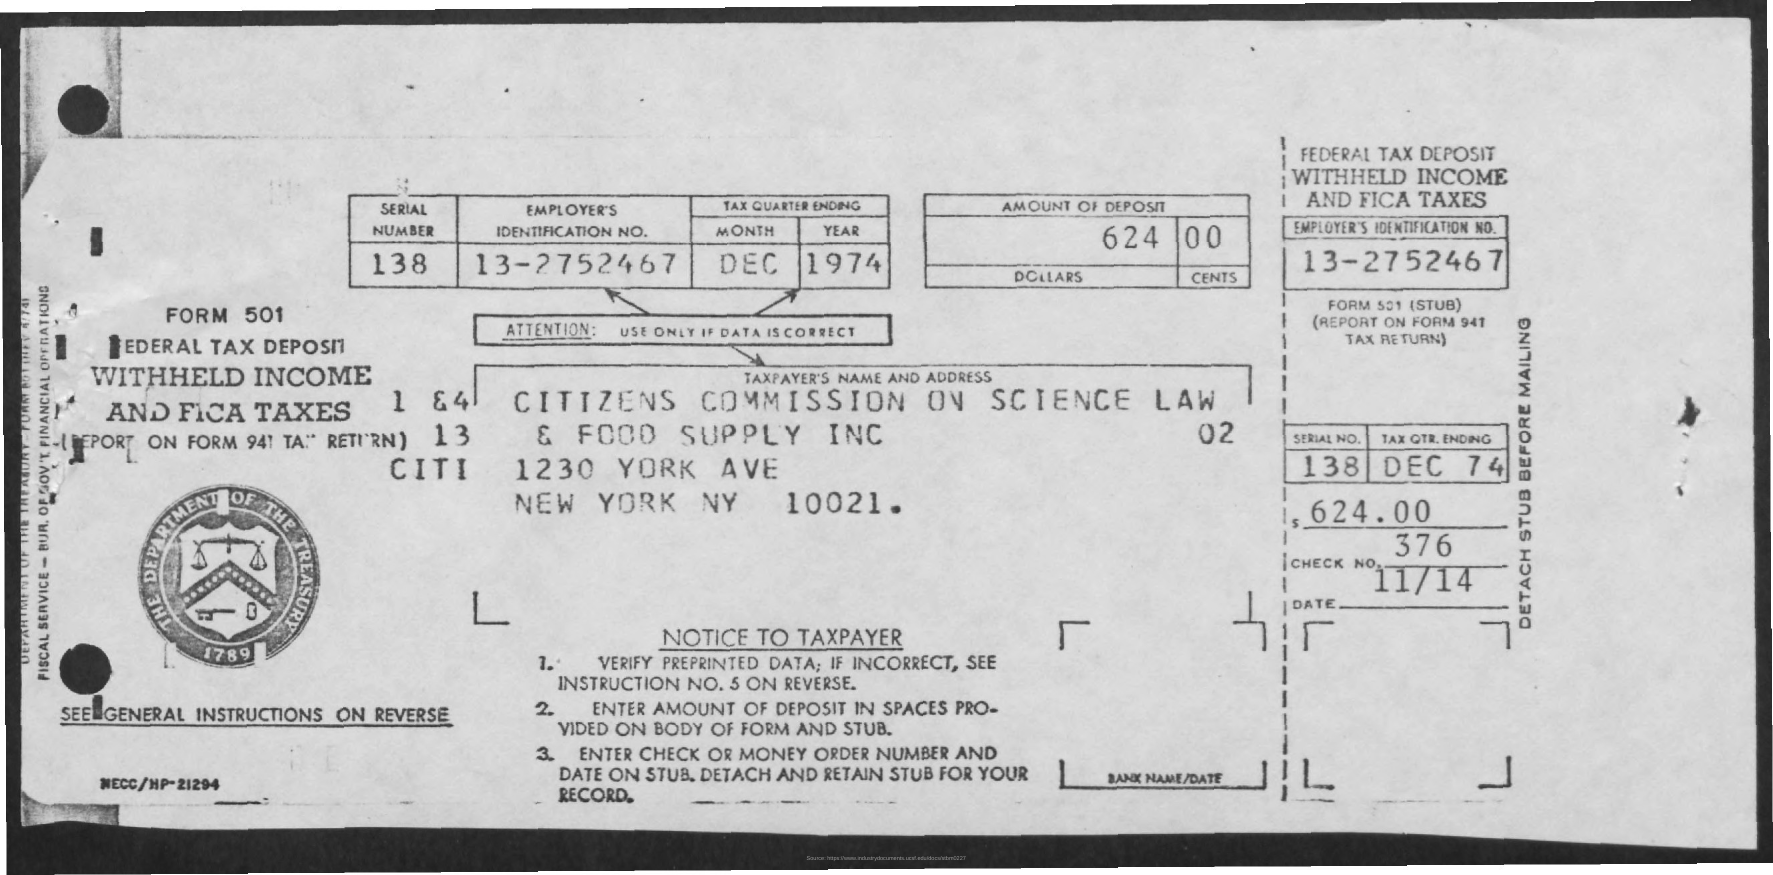How is the form processed after being filled out? After being filled out, the form and any accompanying payment would be submitted to the IRS. The IRS would then use the information and funds provided to credit the employer's tax account for that quarter. A copy of the form might be kept by the employer for record-keeping. 